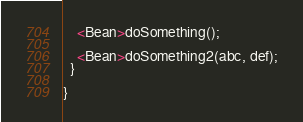Convert code to text. <code><loc_0><loc_0><loc_500><loc_500><_Java_>    <Bean>doSomething();

    <Bean>doSomething2(abc, def);
  }

}
</code> 